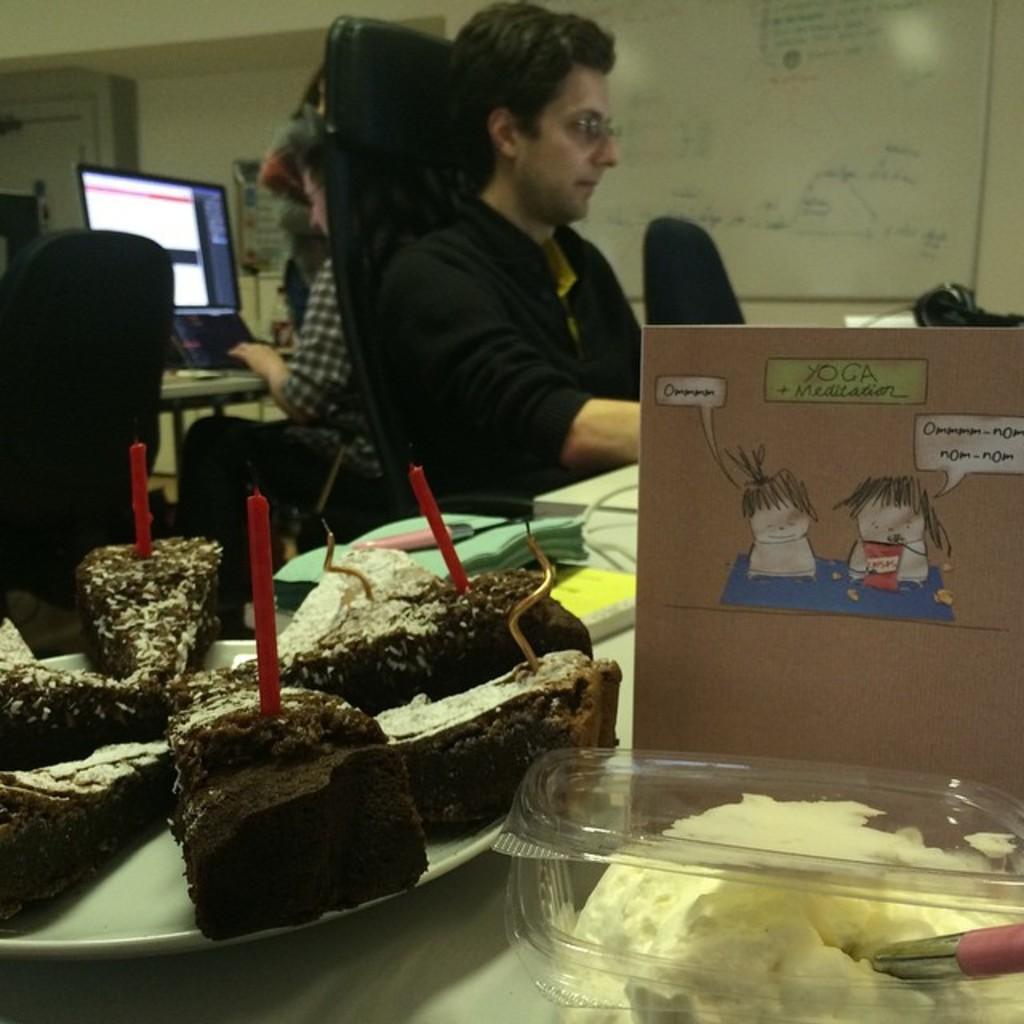Could you give a brief overview of what you see in this image? In this image we can see few people. There are two persons sitting on the chair. There are many objects placed on the table. There are few chairs in the image. 